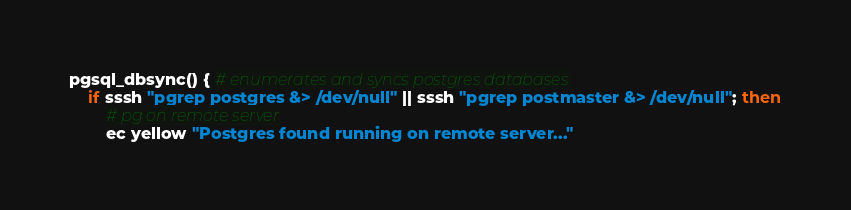<code> <loc_0><loc_0><loc_500><loc_500><_Bash_>pgsql_dbsync() { # enumerates and syncs postgres databases
	if sssh "pgrep postgres &> /dev/null" || sssh "pgrep postmaster &> /dev/null"; then
		# pg on remote server
		ec yellow "Postgres found running on remote server..."</code> 